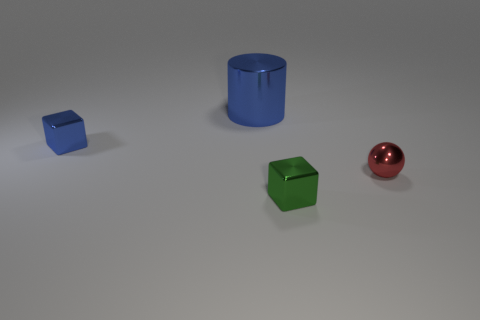There is a object that is the same color as the big cylinder; what is it made of?
Your response must be concise. Metal. There is a object that is the same color as the big cylinder; what shape is it?
Your answer should be very brief. Cube. There is a shiny cube that is the same color as the big cylinder; what size is it?
Provide a short and direct response. Small. There is a metallic thing that is in front of the red sphere; how big is it?
Keep it short and to the point. Small. Is the size of the green cube the same as the shiny cylinder that is to the right of the tiny blue block?
Your answer should be compact. No. What is the color of the sphere that is on the right side of the small shiny cube that is on the left side of the green shiny thing?
Give a very brief answer. Red. What number of other things are the same color as the large thing?
Provide a short and direct response. 1. The blue shiny block is what size?
Your response must be concise. Small. Are there more blue metallic cylinders in front of the cylinder than objects in front of the green metallic block?
Offer a terse response. No. There is a cube that is behind the tiny green object; how many red metallic balls are on the left side of it?
Give a very brief answer. 0. 